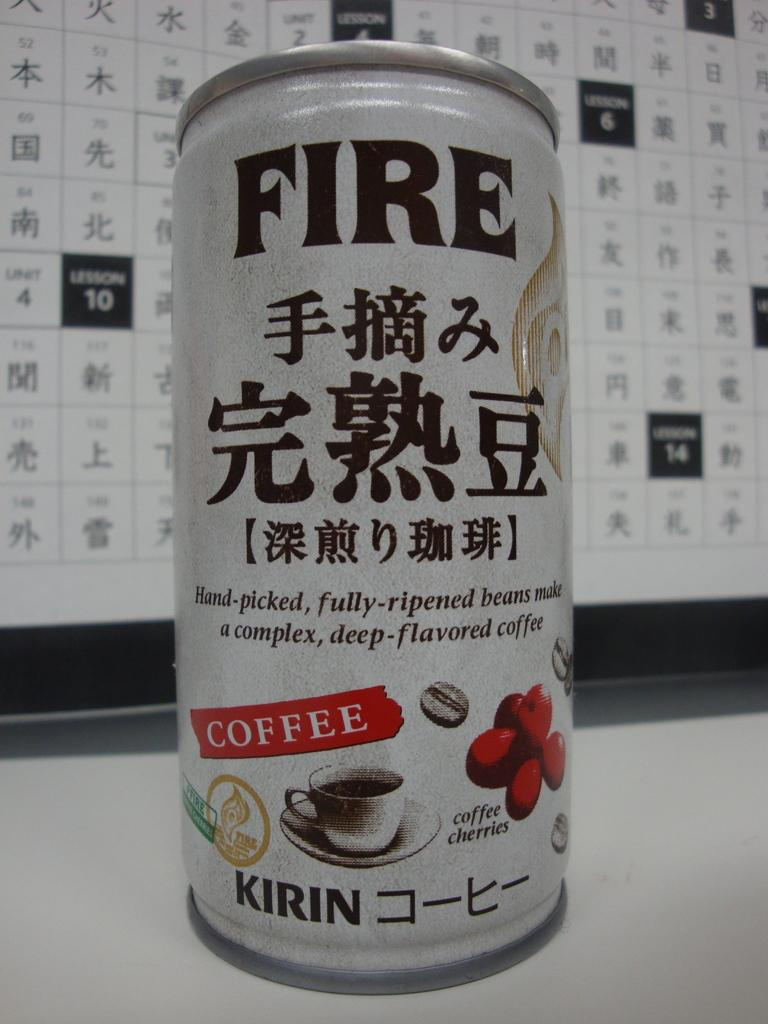What type of beverage container is present in the image? There is a coke can in the image. What is written on the coke can? The word "FIRE" is printed on the coke can in black color. What month is depicted on the coke can in the image? There is no month depicted on the coke can in the image; it only has the word "FIRE" printed on it. 